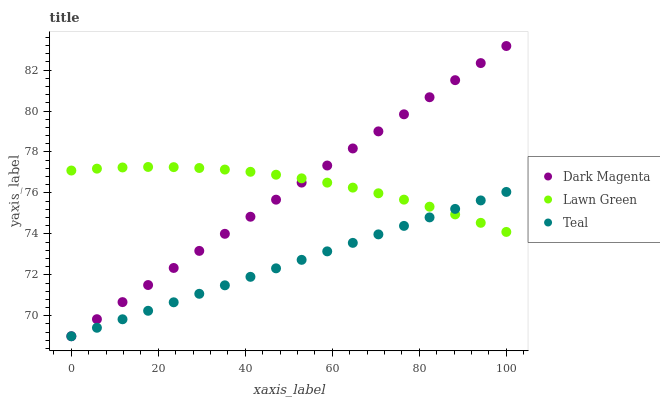Does Teal have the minimum area under the curve?
Answer yes or no. Yes. Does Lawn Green have the maximum area under the curve?
Answer yes or no. Yes. Does Dark Magenta have the minimum area under the curve?
Answer yes or no. No. Does Dark Magenta have the maximum area under the curve?
Answer yes or no. No. Is Teal the smoothest?
Answer yes or no. Yes. Is Lawn Green the roughest?
Answer yes or no. Yes. Is Dark Magenta the smoothest?
Answer yes or no. No. Is Dark Magenta the roughest?
Answer yes or no. No. Does Dark Magenta have the lowest value?
Answer yes or no. Yes. Does Dark Magenta have the highest value?
Answer yes or no. Yes. Does Teal have the highest value?
Answer yes or no. No. Does Lawn Green intersect Dark Magenta?
Answer yes or no. Yes. Is Lawn Green less than Dark Magenta?
Answer yes or no. No. Is Lawn Green greater than Dark Magenta?
Answer yes or no. No. 